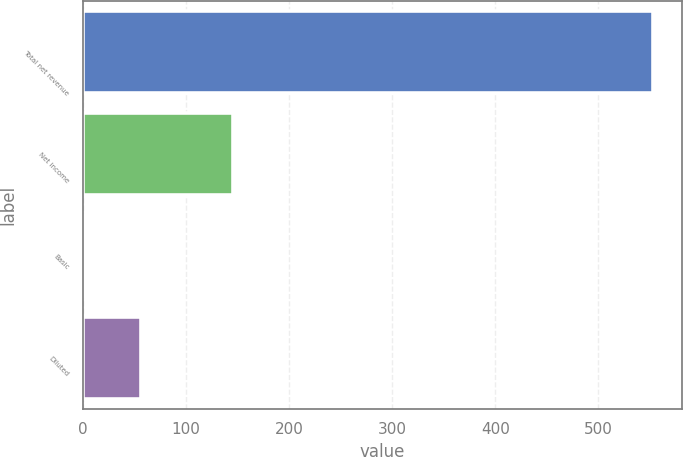Convert chart to OTSL. <chart><loc_0><loc_0><loc_500><loc_500><bar_chart><fcel>Total net revenue<fcel>Net income<fcel>Basic<fcel>Diluted<nl><fcel>553<fcel>145<fcel>0.48<fcel>55.73<nl></chart> 